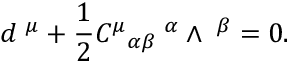<formula> <loc_0><loc_0><loc_500><loc_500>d { \tau } ^ { \mu } + \frac { 1 } { 2 } { C ^ { \mu } } _ { \alpha \beta } { \tau } ^ { \alpha } \wedge { \tau } ^ { \beta } = 0 .</formula> 